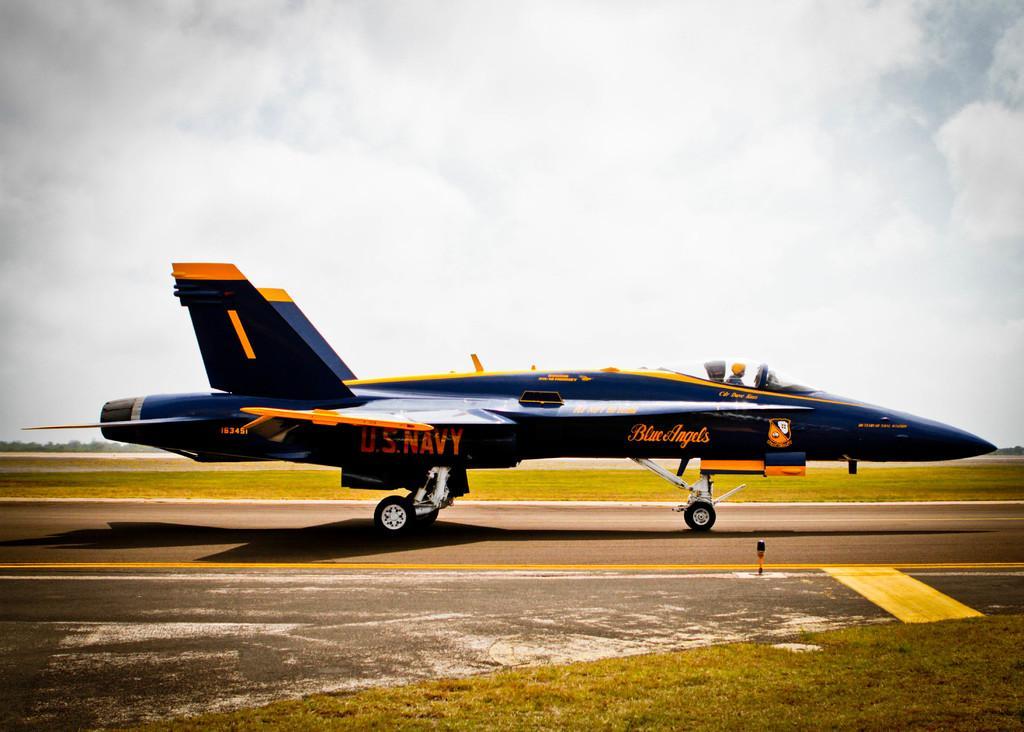How would you summarize this image in a sentence or two? In this image we can see a jet plane standing on the ground. In the background, we can see a cloudy sky. 